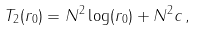Convert formula to latex. <formula><loc_0><loc_0><loc_500><loc_500>T _ { 2 } ( r _ { 0 } ) = N ^ { 2 } \log ( r _ { 0 } ) + N ^ { 2 } c \, ,</formula> 